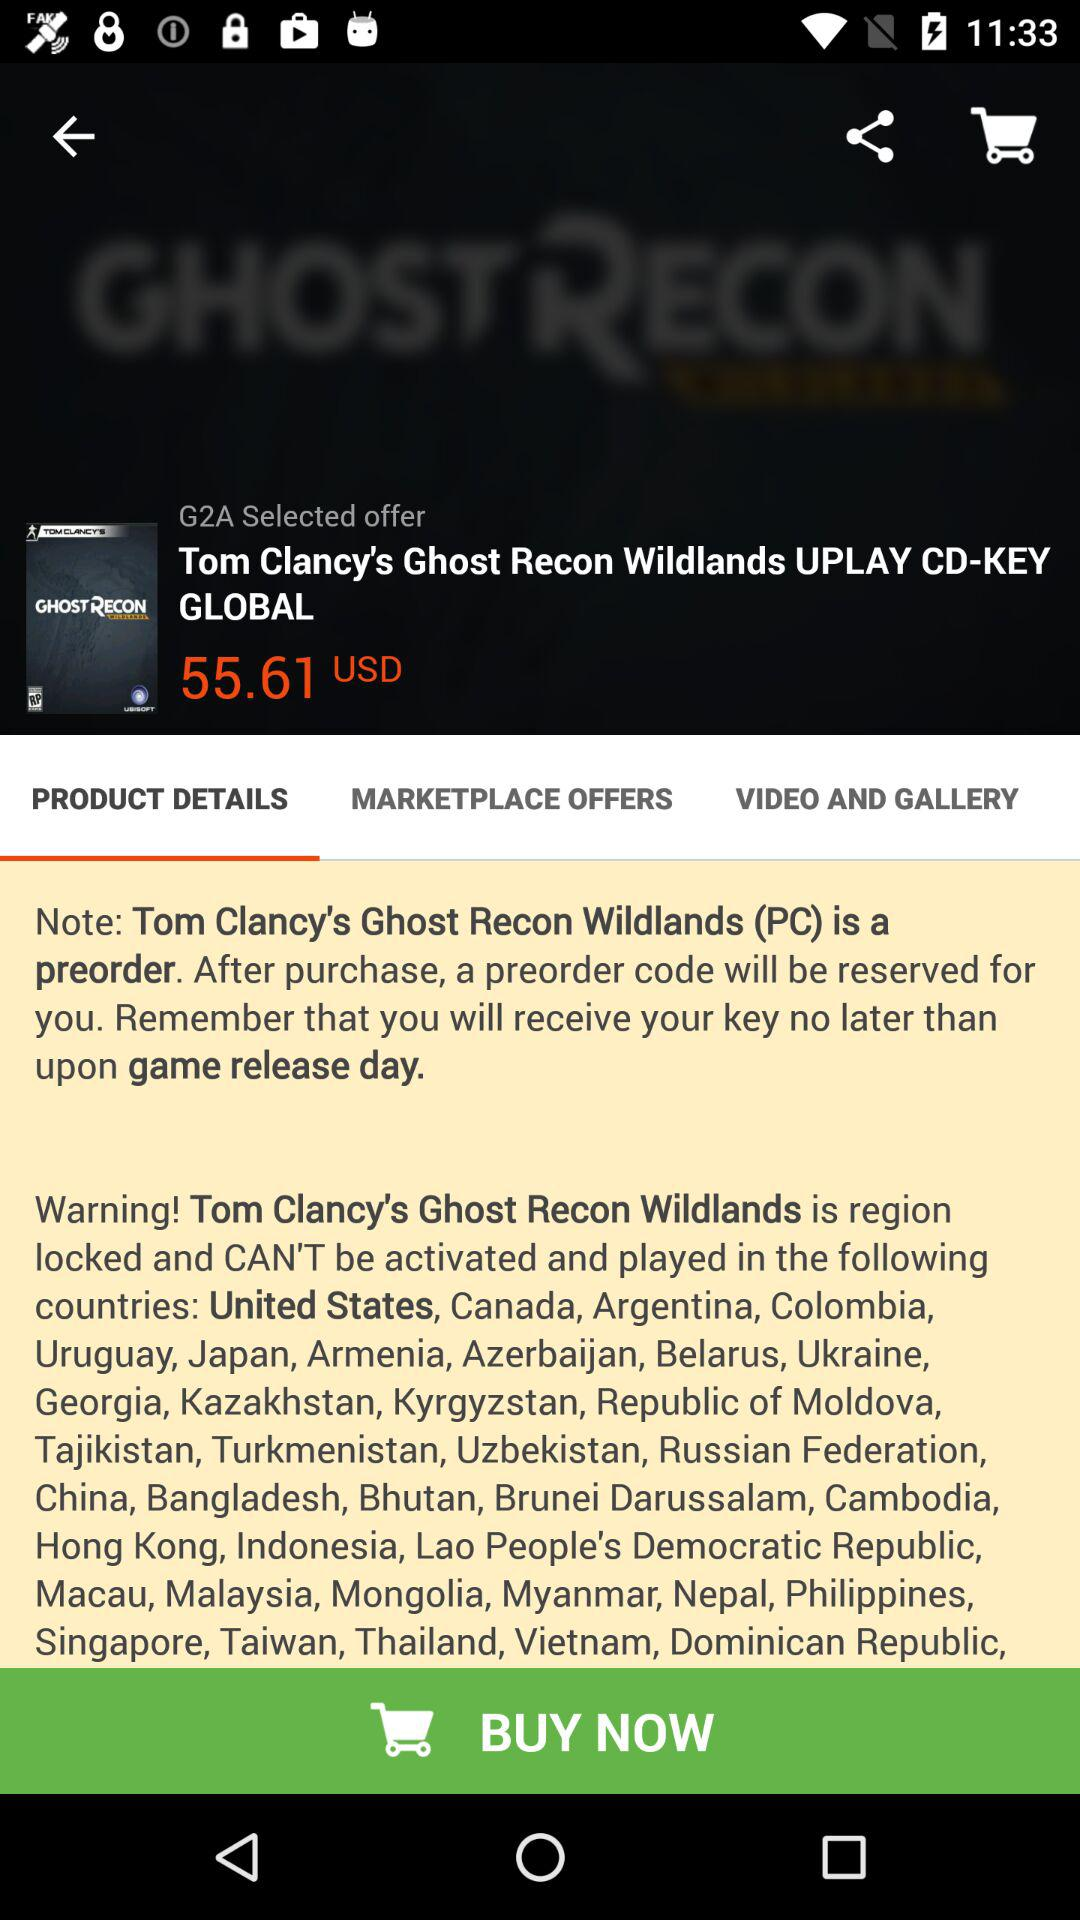In which countries is the game "Tom Clancy's Ghost Recon Wildlands" locked? The game is locked in the United States, Canada, Argentina, Colombia, Uruguay, Japan, Armenia, Azerbaijan, Belarus, Ukraine, Georgia, Kazakhstan, Kyrgyzstan, Republic of Moldova, Tajikistan, Turkmenistan, Uzbekistan, the Russian Federation, China, Bangladesh, Bhutan, Brunei Darussalam, Cambodia, Hong Kong, Indonesia, Lao People's Democratic Republic, Macau, Malaysia, Mongolia, Myanmar, Nepal, the Philippines, Singapore, Taiwan, Thailand, Vietnam and the Dominican Republic. 